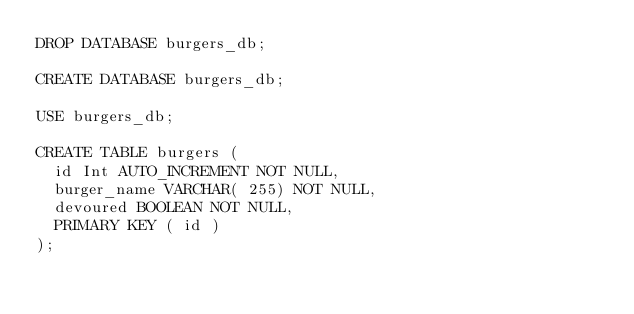<code> <loc_0><loc_0><loc_500><loc_500><_SQL_>DROP DATABASE burgers_db;

CREATE DATABASE burgers_db;

USE burgers_db;

CREATE TABLE burgers (
  id Int AUTO_INCREMENT NOT NULL,
  burger_name VARCHAR( 255) NOT NULL,
  devoured BOOLEAN NOT NULL,
  PRIMARY KEY ( id ) 
);</code> 